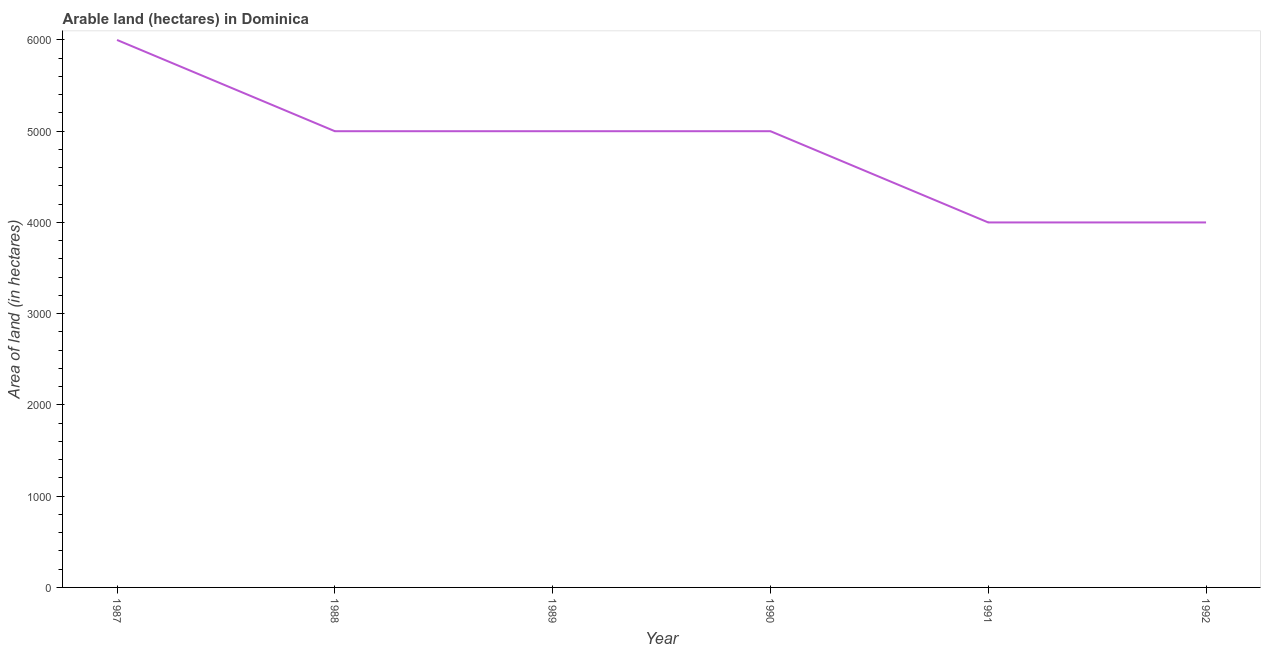What is the area of land in 1992?
Offer a very short reply. 4000. Across all years, what is the maximum area of land?
Your answer should be compact. 6000. Across all years, what is the minimum area of land?
Provide a short and direct response. 4000. In which year was the area of land maximum?
Keep it short and to the point. 1987. In which year was the area of land minimum?
Offer a terse response. 1991. What is the sum of the area of land?
Offer a very short reply. 2.90e+04. What is the average area of land per year?
Your answer should be compact. 4833.33. Is the area of land in 1991 less than that in 1992?
Offer a terse response. No. What is the difference between the highest and the second highest area of land?
Make the answer very short. 1000. Is the sum of the area of land in 1989 and 1992 greater than the maximum area of land across all years?
Ensure brevity in your answer.  Yes. How many lines are there?
Give a very brief answer. 1. How many years are there in the graph?
Keep it short and to the point. 6. What is the difference between two consecutive major ticks on the Y-axis?
Provide a short and direct response. 1000. Does the graph contain any zero values?
Ensure brevity in your answer.  No. What is the title of the graph?
Give a very brief answer. Arable land (hectares) in Dominica. What is the label or title of the X-axis?
Offer a terse response. Year. What is the label or title of the Y-axis?
Your answer should be compact. Area of land (in hectares). What is the Area of land (in hectares) of 1987?
Keep it short and to the point. 6000. What is the Area of land (in hectares) of 1988?
Your answer should be compact. 5000. What is the Area of land (in hectares) in 1991?
Offer a terse response. 4000. What is the Area of land (in hectares) in 1992?
Give a very brief answer. 4000. What is the difference between the Area of land (in hectares) in 1987 and 1989?
Your answer should be compact. 1000. What is the difference between the Area of land (in hectares) in 1987 and 1990?
Your answer should be very brief. 1000. What is the difference between the Area of land (in hectares) in 1987 and 1992?
Keep it short and to the point. 2000. What is the difference between the Area of land (in hectares) in 1988 and 1990?
Keep it short and to the point. 0. What is the difference between the Area of land (in hectares) in 1988 and 1992?
Your answer should be very brief. 1000. What is the difference between the Area of land (in hectares) in 1989 and 1990?
Provide a succinct answer. 0. What is the difference between the Area of land (in hectares) in 1989 and 1992?
Offer a terse response. 1000. What is the difference between the Area of land (in hectares) in 1990 and 1991?
Offer a terse response. 1000. What is the difference between the Area of land (in hectares) in 1990 and 1992?
Your answer should be compact. 1000. What is the ratio of the Area of land (in hectares) in 1987 to that in 1988?
Your response must be concise. 1.2. What is the ratio of the Area of land (in hectares) in 1988 to that in 1989?
Provide a short and direct response. 1. What is the ratio of the Area of land (in hectares) in 1988 to that in 1990?
Your response must be concise. 1. What is the ratio of the Area of land (in hectares) in 1989 to that in 1990?
Provide a succinct answer. 1. What is the ratio of the Area of land (in hectares) in 1989 to that in 1991?
Give a very brief answer. 1.25. What is the ratio of the Area of land (in hectares) in 1990 to that in 1991?
Your answer should be very brief. 1.25. What is the ratio of the Area of land (in hectares) in 1990 to that in 1992?
Offer a very short reply. 1.25. What is the ratio of the Area of land (in hectares) in 1991 to that in 1992?
Your response must be concise. 1. 